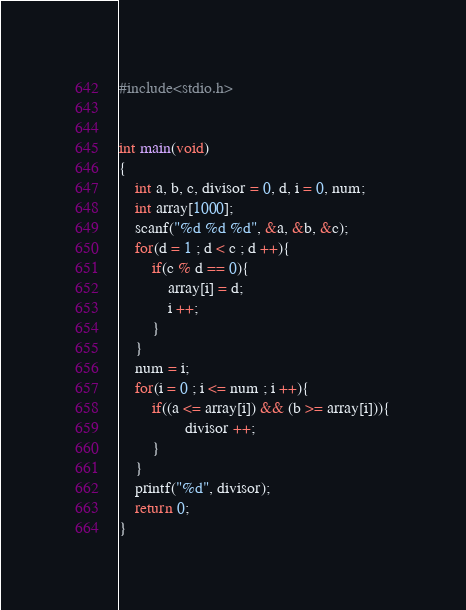Convert code to text. <code><loc_0><loc_0><loc_500><loc_500><_C_>#include<stdio.h>


int main(void)
{
    int a, b, c, divisor = 0, d, i = 0, num;
    int array[1000];
    scanf("%d %d %d", &a, &b, &c);
    for(d = 1 ; d < c ; d ++){
        if(c % d == 0){
            array[i] = d;
            i ++;
        }
    }
    num = i;
    for(i = 0 ; i <= num ; i ++){
        if((a <= array[i]) && (b >= array[i])){
                divisor ++;
        }
    }
    printf("%d", divisor);
    return 0;
}</code> 